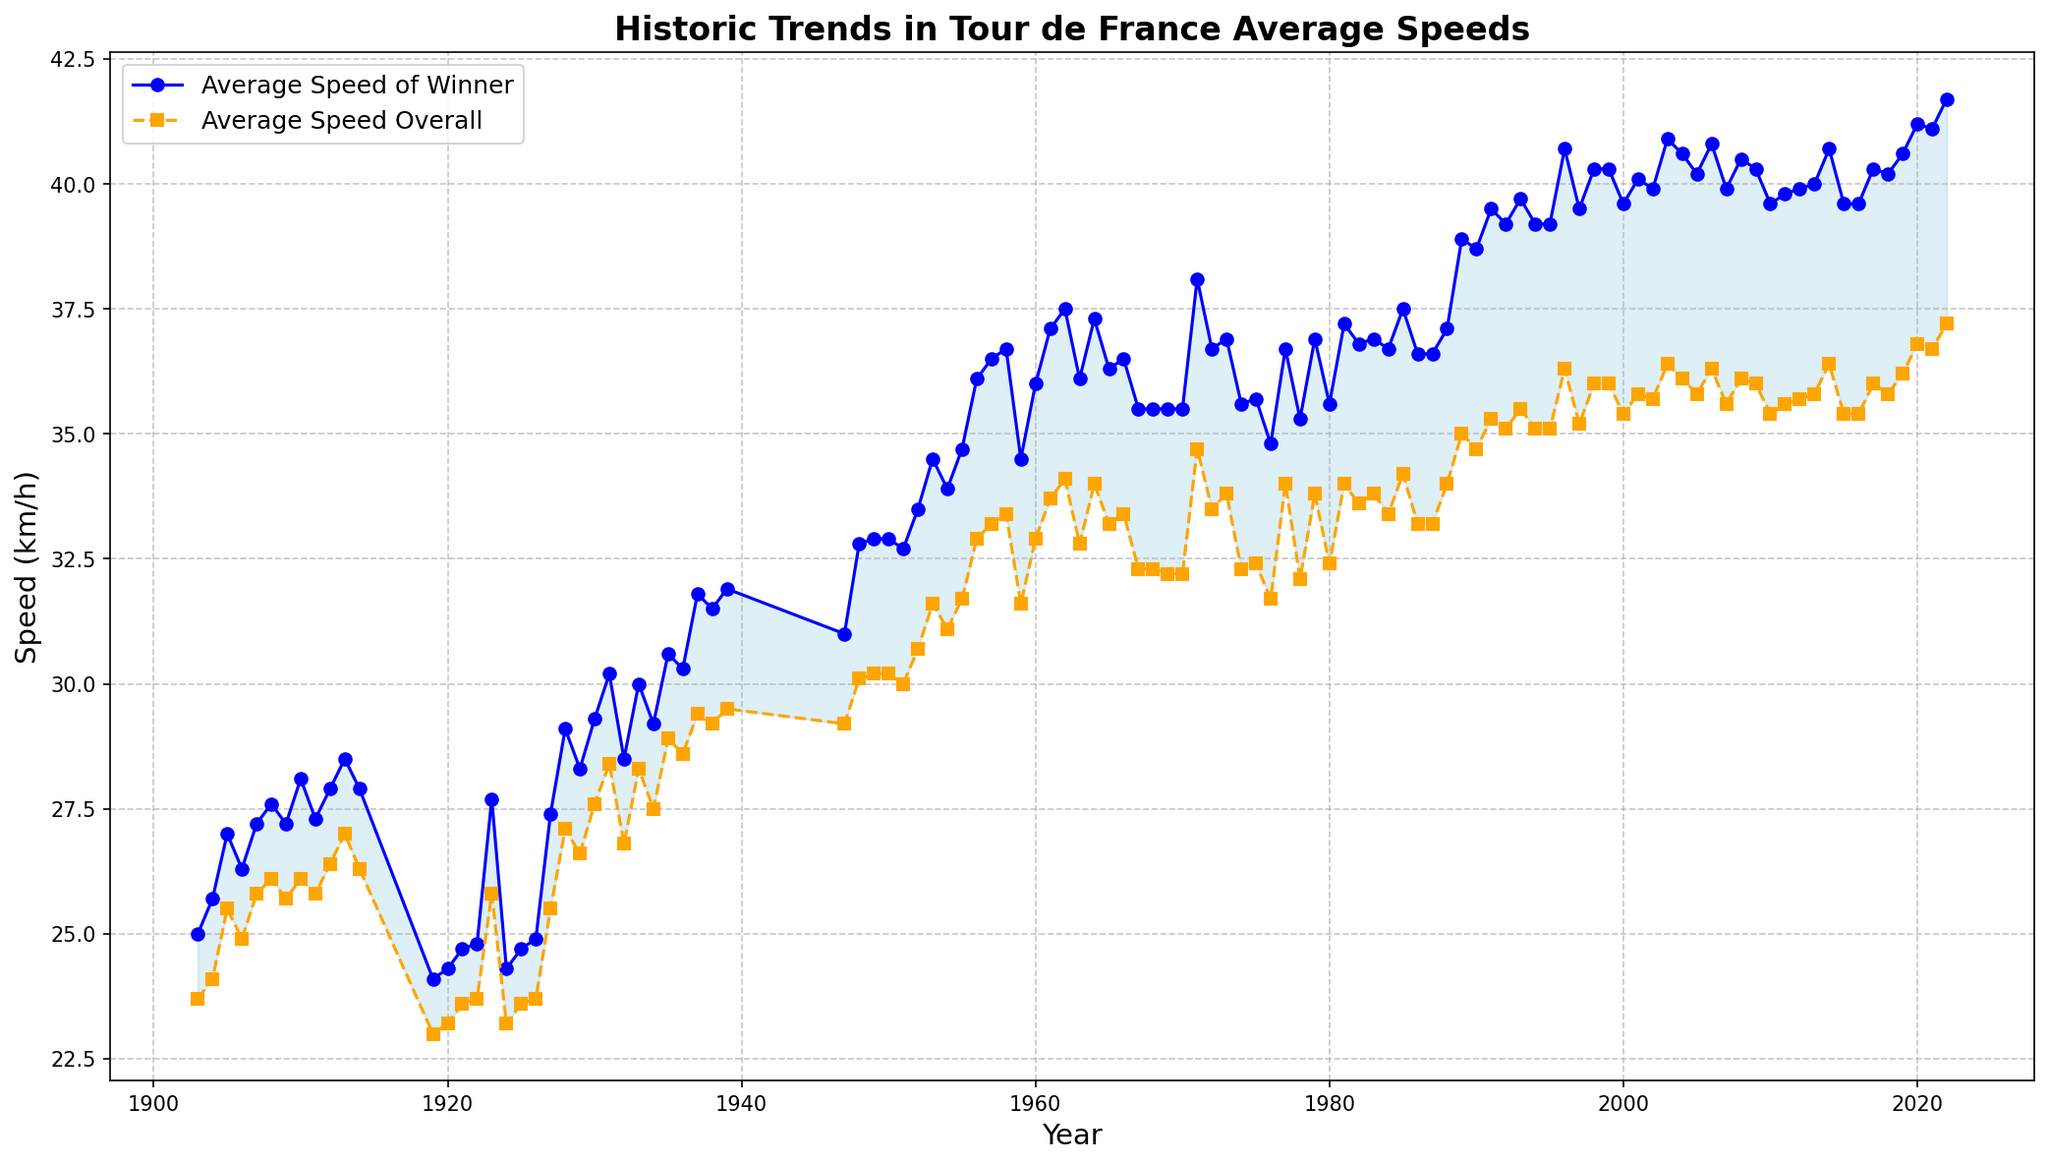What year did the overall competitors’ average speed first exceed 30 km/h? Look at the orange dashed line and identify the first point where the speed exceeds 30 km/h. It occurs in the year 1938.
Answer: 1938 What is the difference in speed between the winner and the overall competitors in the year 1971? Find the speeds for both the winner and the overall competitors for 1971 and subtract the latter from the former: 38.1 km/h - 34.7 km/h = 3.4 km/h
Answer: 3.4 km/h Which year shows the largest gap between the winner’s average speed and the overall competitors’ average speed? Identify the largest vertical distance between the two lines. This occurs in the year 2022 where the difference is largest.
Answer: 2022 From 1903 to 2022, how does the trend of average speed of the winners compare to the overall competitors? Observe both lines from the beginning to the end. Both lines exhibit a general upward trend, but the winner’s speeds consistently remain higher than the overall competitors'.
Answer: Winner's speed increases consistently, always higher Which section of the time period shows a noticeable dip for both the winner and overall average speeds? Look for the area where both lines show a downward trend or dip. This is noticeable around the period of World War I (1913-1919).
Answer: Around World War I (1913-1919) In which decades did the average speed of the overall competitors stay almost constant? Observe the orange dashed line for relatively flat segments. Both the 1960s (1961-1970) and the early 2000s (2000-2010) show periods where the overall average speeds are quite stable.
Answer: 1960s and early 2000s How does the average speed in the 1920s compare to the 1930s for both winners and overall competitors? Compare the positions of both lines in the 1920s and 1930s. The 1930s show consistently higher average speeds than the 1920s for both winners and overall competitors.
Answer: 1930s faster for both What is the approximate average speed difference between winners and overall competitors over the entire period? Calculate the average speeds for each group over all years, then find their difference. It can be visually estimated to be around 4-5 km/h.
Answer: Approximately 4-5 km/h 